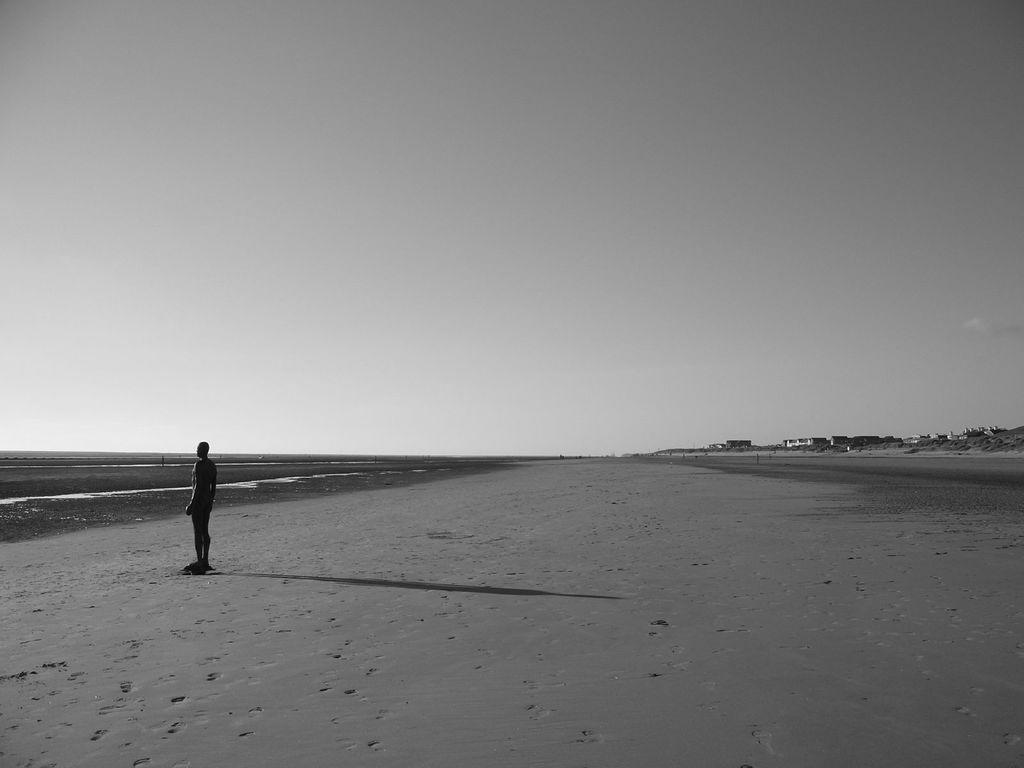Describe this image in one or two sentences. It is a black and white image. On the left side of the image, we can see a person is standing on the sand. Background we can see houses and sky. 